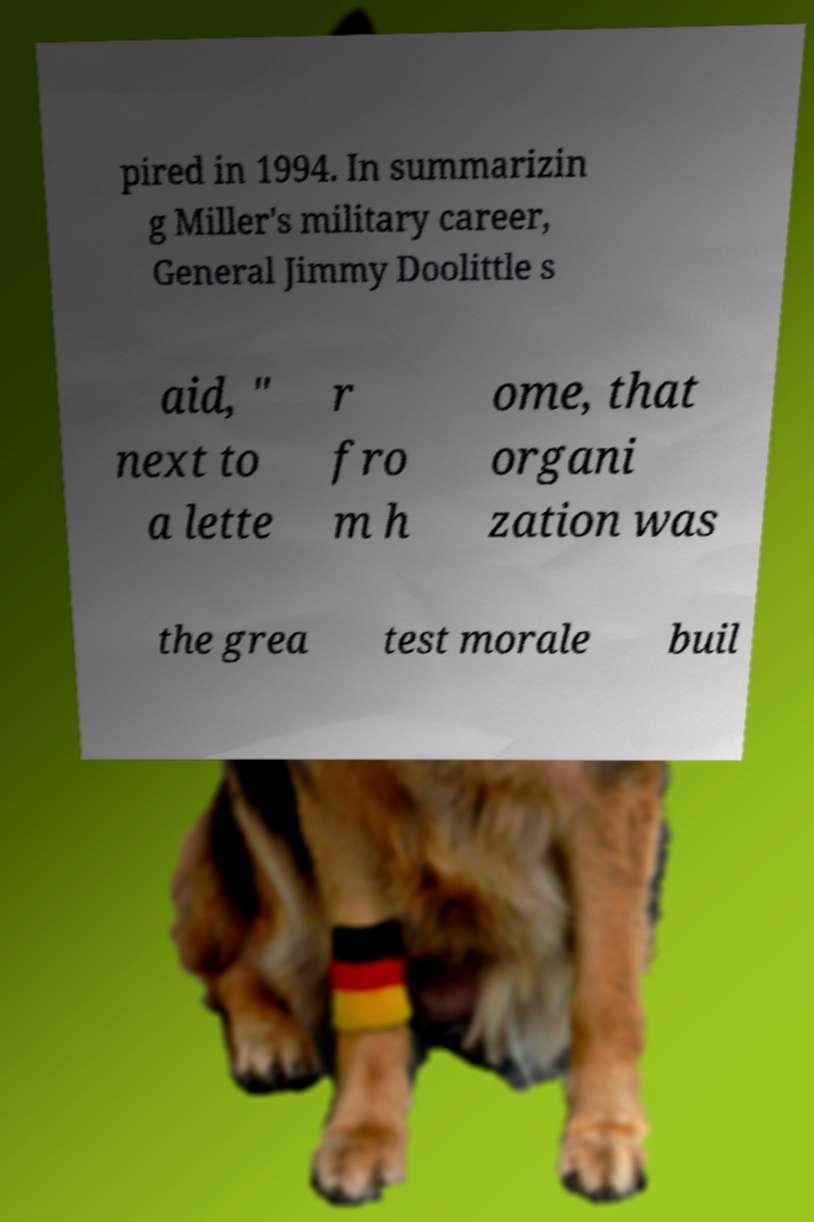What messages or text are displayed in this image? I need them in a readable, typed format. pired in 1994. In summarizin g Miller's military career, General Jimmy Doolittle s aid, " next to a lette r fro m h ome, that organi zation was the grea test morale buil 